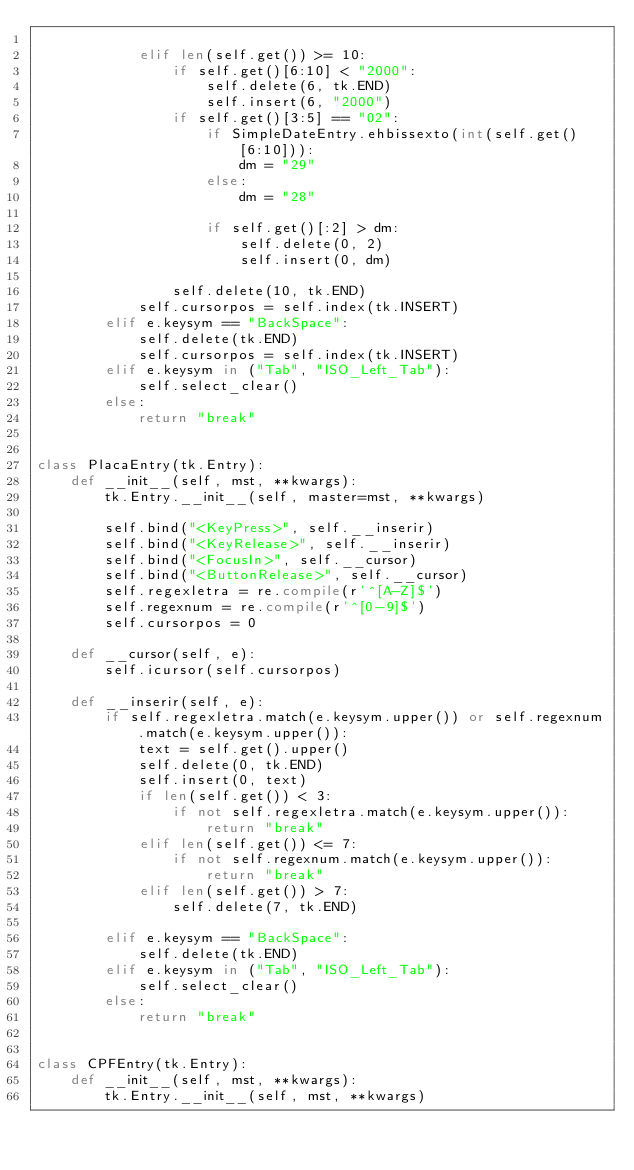<code> <loc_0><loc_0><loc_500><loc_500><_Python_>
            elif len(self.get()) >= 10:
                if self.get()[6:10] < "2000":
                    self.delete(6, tk.END)
                    self.insert(6, "2000")
                if self.get()[3:5] == "02":
                    if SimpleDateEntry.ehbissexto(int(self.get()[6:10])):
                        dm = "29"
                    else:
                        dm = "28"

                    if self.get()[:2] > dm:
                        self.delete(0, 2)
                        self.insert(0, dm)

                self.delete(10, tk.END)
            self.cursorpos = self.index(tk.INSERT)
        elif e.keysym == "BackSpace":
            self.delete(tk.END)
            self.cursorpos = self.index(tk.INSERT)
        elif e.keysym in ("Tab", "ISO_Left_Tab"):
            self.select_clear()
        else:
            return "break"


class PlacaEntry(tk.Entry):
    def __init__(self, mst, **kwargs):
        tk.Entry.__init__(self, master=mst, **kwargs)

        self.bind("<KeyPress>", self.__inserir)
        self.bind("<KeyRelease>", self.__inserir)
        self.bind("<FocusIn>", self.__cursor)
        self.bind("<ButtonRelease>", self.__cursor)
        self.regexletra = re.compile(r'^[A-Z]$')
        self.regexnum = re.compile(r'^[0-9]$')
        self.cursorpos = 0

    def __cursor(self, e):
        self.icursor(self.cursorpos)

    def __inserir(self, e):
        if self.regexletra.match(e.keysym.upper()) or self.regexnum.match(e.keysym.upper()):
            text = self.get().upper()
            self.delete(0, tk.END)
            self.insert(0, text)
            if len(self.get()) < 3:
                if not self.regexletra.match(e.keysym.upper()):
                    return "break"
            elif len(self.get()) <= 7:
                if not self.regexnum.match(e.keysym.upper()):
                    return "break"
            elif len(self.get()) > 7:
                self.delete(7, tk.END)

        elif e.keysym == "BackSpace":
            self.delete(tk.END)
        elif e.keysym in ("Tab", "ISO_Left_Tab"):
            self.select_clear()
        else:
            return "break"


class CPFEntry(tk.Entry):
    def __init__(self, mst, **kwargs):
        tk.Entry.__init__(self, mst, **kwargs)

</code> 